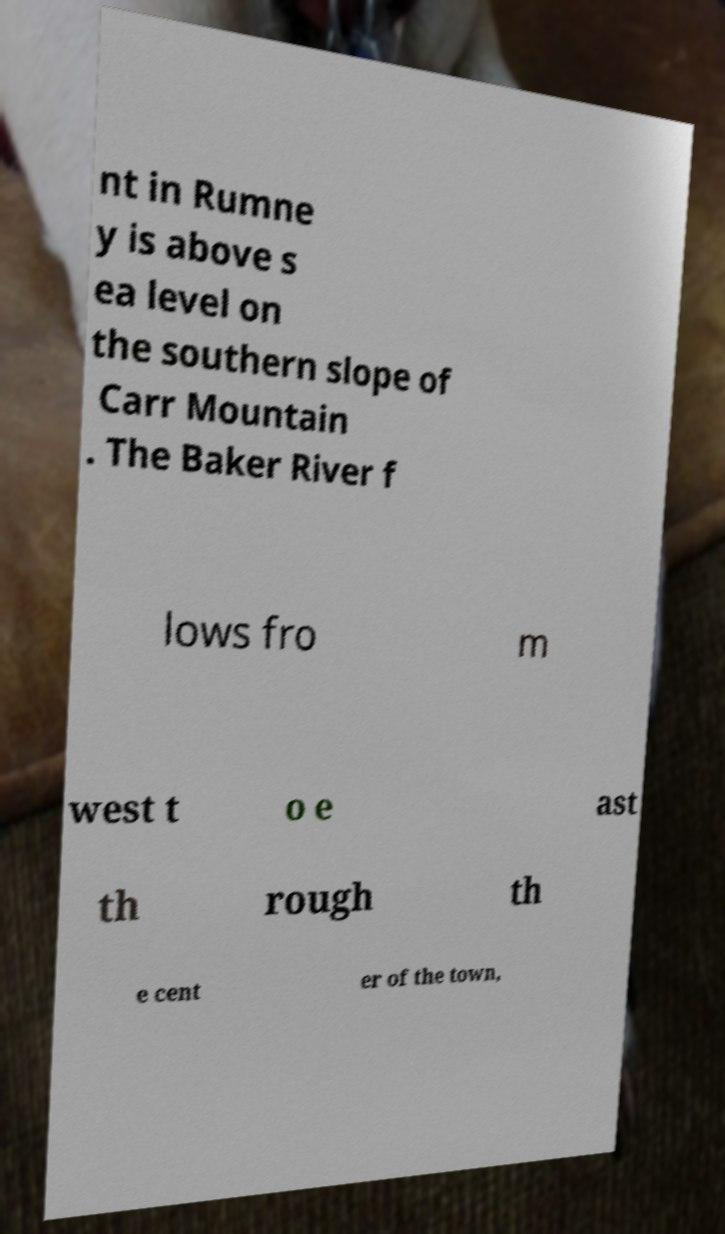Could you assist in decoding the text presented in this image and type it out clearly? nt in Rumne y is above s ea level on the southern slope of Carr Mountain . The Baker River f lows fro m west t o e ast th rough th e cent er of the town, 